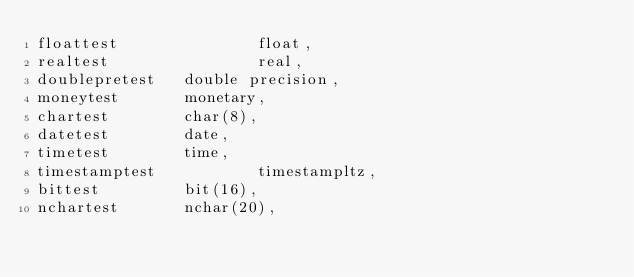Convert code to text. <code><loc_0><loc_0><loc_500><loc_500><_SQL_>floattest               float,
realtest                real,
doublepretest   double precision,
moneytest       monetary,
chartest        char(8),
datetest        date,
timetest        time,
timestamptest           timestampltz,
bittest         bit(16),
nchartest       nchar(20),</code> 